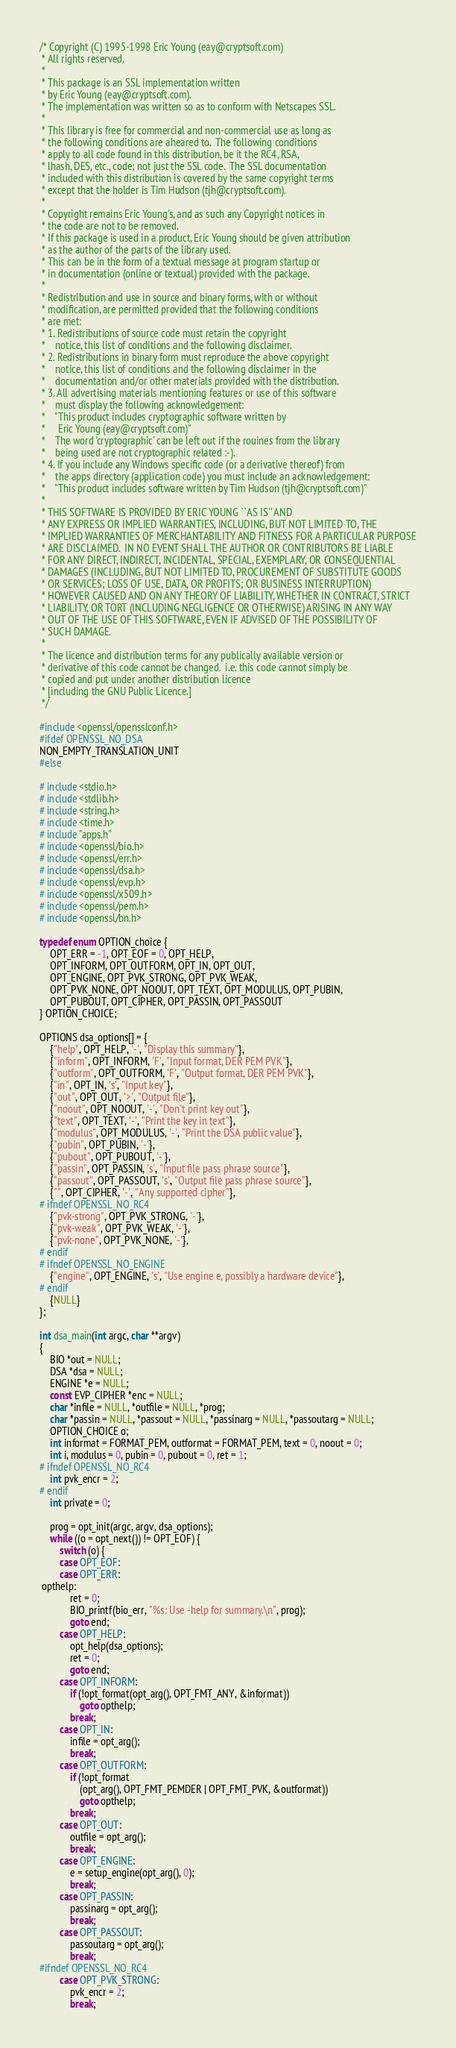<code> <loc_0><loc_0><loc_500><loc_500><_C_>/* Copyright (C) 1995-1998 Eric Young (eay@cryptsoft.com)
 * All rights reserved.
 *
 * This package is an SSL implementation written
 * by Eric Young (eay@cryptsoft.com).
 * The implementation was written so as to conform with Netscapes SSL.
 *
 * This library is free for commercial and non-commercial use as long as
 * the following conditions are aheared to.  The following conditions
 * apply to all code found in this distribution, be it the RC4, RSA,
 * lhash, DES, etc., code; not just the SSL code.  The SSL documentation
 * included with this distribution is covered by the same copyright terms
 * except that the holder is Tim Hudson (tjh@cryptsoft.com).
 *
 * Copyright remains Eric Young's, and as such any Copyright notices in
 * the code are not to be removed.
 * If this package is used in a product, Eric Young should be given attribution
 * as the author of the parts of the library used.
 * This can be in the form of a textual message at program startup or
 * in documentation (online or textual) provided with the package.
 *
 * Redistribution and use in source and binary forms, with or without
 * modification, are permitted provided that the following conditions
 * are met:
 * 1. Redistributions of source code must retain the copyright
 *    notice, this list of conditions and the following disclaimer.
 * 2. Redistributions in binary form must reproduce the above copyright
 *    notice, this list of conditions and the following disclaimer in the
 *    documentation and/or other materials provided with the distribution.
 * 3. All advertising materials mentioning features or use of this software
 *    must display the following acknowledgement:
 *    "This product includes cryptographic software written by
 *     Eric Young (eay@cryptsoft.com)"
 *    The word 'cryptographic' can be left out if the rouines from the library
 *    being used are not cryptographic related :-).
 * 4. If you include any Windows specific code (or a derivative thereof) from
 *    the apps directory (application code) you must include an acknowledgement:
 *    "This product includes software written by Tim Hudson (tjh@cryptsoft.com)"
 *
 * THIS SOFTWARE IS PROVIDED BY ERIC YOUNG ``AS IS'' AND
 * ANY EXPRESS OR IMPLIED WARRANTIES, INCLUDING, BUT NOT LIMITED TO, THE
 * IMPLIED WARRANTIES OF MERCHANTABILITY AND FITNESS FOR A PARTICULAR PURPOSE
 * ARE DISCLAIMED.  IN NO EVENT SHALL THE AUTHOR OR CONTRIBUTORS BE LIABLE
 * FOR ANY DIRECT, INDIRECT, INCIDENTAL, SPECIAL, EXEMPLARY, OR CONSEQUENTIAL
 * DAMAGES (INCLUDING, BUT NOT LIMITED TO, PROCUREMENT OF SUBSTITUTE GOODS
 * OR SERVICES; LOSS OF USE, DATA, OR PROFITS; OR BUSINESS INTERRUPTION)
 * HOWEVER CAUSED AND ON ANY THEORY OF LIABILITY, WHETHER IN CONTRACT, STRICT
 * LIABILITY, OR TORT (INCLUDING NEGLIGENCE OR OTHERWISE) ARISING IN ANY WAY
 * OUT OF THE USE OF THIS SOFTWARE, EVEN IF ADVISED OF THE POSSIBILITY OF
 * SUCH DAMAGE.
 *
 * The licence and distribution terms for any publically available version or
 * derivative of this code cannot be changed.  i.e. this code cannot simply be
 * copied and put under another distribution licence
 * [including the GNU Public Licence.]
 */

#include <openssl/opensslconf.h>
#ifdef OPENSSL_NO_DSA
NON_EMPTY_TRANSLATION_UNIT
#else

# include <stdio.h>
# include <stdlib.h>
# include <string.h>
# include <time.h>
# include "apps.h"
# include <openssl/bio.h>
# include <openssl/err.h>
# include <openssl/dsa.h>
# include <openssl/evp.h>
# include <openssl/x509.h>
# include <openssl/pem.h>
# include <openssl/bn.h>

typedef enum OPTION_choice {
    OPT_ERR = -1, OPT_EOF = 0, OPT_HELP,
    OPT_INFORM, OPT_OUTFORM, OPT_IN, OPT_OUT,
    OPT_ENGINE, OPT_PVK_STRONG, OPT_PVK_WEAK,
    OPT_PVK_NONE, OPT_NOOUT, OPT_TEXT, OPT_MODULUS, OPT_PUBIN,
    OPT_PUBOUT, OPT_CIPHER, OPT_PASSIN, OPT_PASSOUT
} OPTION_CHOICE;

OPTIONS dsa_options[] = {
    {"help", OPT_HELP, '-', "Display this summary"},
    {"inform", OPT_INFORM, 'F', "Input format, DER PEM PVK"},
    {"outform", OPT_OUTFORM, 'F', "Output format, DER PEM PVK"},
    {"in", OPT_IN, 's', "Input key"},
    {"out", OPT_OUT, '>', "Output file"},
    {"noout", OPT_NOOUT, '-', "Don't print key out"},
    {"text", OPT_TEXT, '-', "Print the key in text"},
    {"modulus", OPT_MODULUS, '-', "Print the DSA public value"},
    {"pubin", OPT_PUBIN, '-'},
    {"pubout", OPT_PUBOUT, '-'},
    {"passin", OPT_PASSIN, 's', "Input file pass phrase source"},
    {"passout", OPT_PASSOUT, 's', "Output file pass phrase source"},
    {"", OPT_CIPHER, '-', "Any supported cipher"},
# ifndef OPENSSL_NO_RC4
    {"pvk-strong", OPT_PVK_STRONG, '-'},
    {"pvk-weak", OPT_PVK_WEAK, '-'},
    {"pvk-none", OPT_PVK_NONE, '-'},
# endif
# ifndef OPENSSL_NO_ENGINE
    {"engine", OPT_ENGINE, 's', "Use engine e, possibly a hardware device"},
# endif
    {NULL}
};

int dsa_main(int argc, char **argv)
{
    BIO *out = NULL;
    DSA *dsa = NULL;
    ENGINE *e = NULL;
    const EVP_CIPHER *enc = NULL;
    char *infile = NULL, *outfile = NULL, *prog;
    char *passin = NULL, *passout = NULL, *passinarg = NULL, *passoutarg = NULL;
    OPTION_CHOICE o;
    int informat = FORMAT_PEM, outformat = FORMAT_PEM, text = 0, noout = 0;
    int i, modulus = 0, pubin = 0, pubout = 0, ret = 1;
# ifndef OPENSSL_NO_RC4
    int pvk_encr = 2;
# endif
    int private = 0;

    prog = opt_init(argc, argv, dsa_options);
    while ((o = opt_next()) != OPT_EOF) {
        switch (o) {
        case OPT_EOF:
        case OPT_ERR:
 opthelp:
            ret = 0;
            BIO_printf(bio_err, "%s: Use -help for summary.\n", prog);
            goto end;
        case OPT_HELP:
            opt_help(dsa_options);
            ret = 0;
            goto end;
        case OPT_INFORM:
            if (!opt_format(opt_arg(), OPT_FMT_ANY, &informat))
                goto opthelp;
            break;
        case OPT_IN:
            infile = opt_arg();
            break;
        case OPT_OUTFORM:
            if (!opt_format
                (opt_arg(), OPT_FMT_PEMDER | OPT_FMT_PVK, &outformat))
                goto opthelp;
            break;
        case OPT_OUT:
            outfile = opt_arg();
            break;
        case OPT_ENGINE:
            e = setup_engine(opt_arg(), 0);
            break;
        case OPT_PASSIN:
            passinarg = opt_arg();
            break;
        case OPT_PASSOUT:
            passoutarg = opt_arg();
            break;
#ifndef OPENSSL_NO_RC4
        case OPT_PVK_STRONG:
            pvk_encr = 2;
            break;</code> 